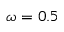<formula> <loc_0><loc_0><loc_500><loc_500>\omega = 0 . 5</formula> 